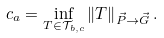<formula> <loc_0><loc_0><loc_500><loc_500>c _ { a } = \inf _ { T \in \mathcal { T } _ { b , c } } \left \| T \right \| _ { \vec { P } \rightarrow \vec { G } } .</formula> 